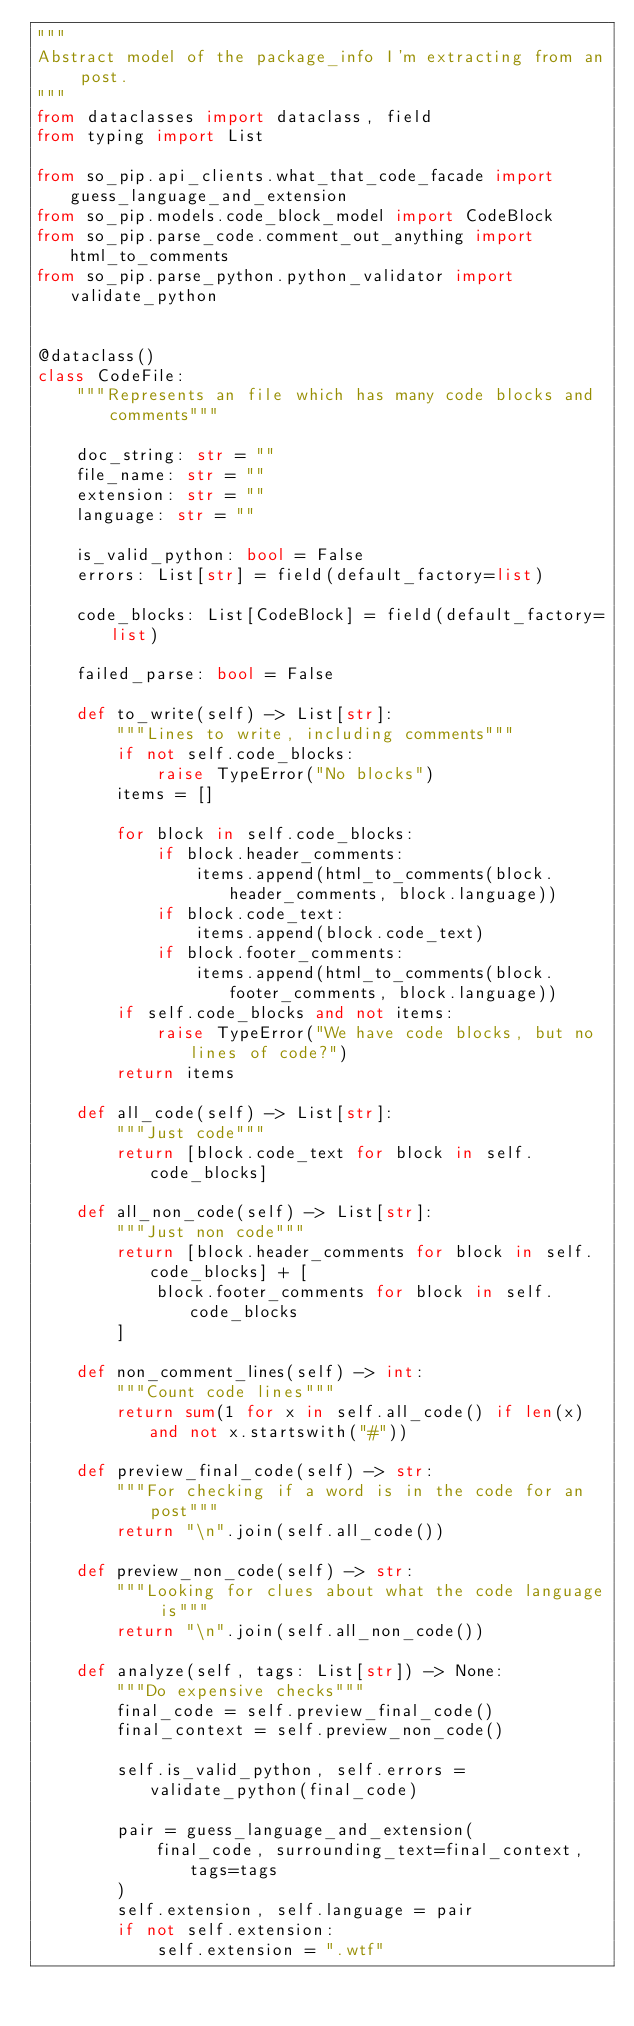<code> <loc_0><loc_0><loc_500><loc_500><_Python_>"""
Abstract model of the package_info I'm extracting from an post.
"""
from dataclasses import dataclass, field
from typing import List

from so_pip.api_clients.what_that_code_facade import guess_language_and_extension
from so_pip.models.code_block_model import CodeBlock
from so_pip.parse_code.comment_out_anything import html_to_comments
from so_pip.parse_python.python_validator import validate_python


@dataclass()
class CodeFile:
    """Represents an file which has many code blocks and comments"""

    doc_string: str = ""
    file_name: str = ""
    extension: str = ""
    language: str = ""

    is_valid_python: bool = False
    errors: List[str] = field(default_factory=list)

    code_blocks: List[CodeBlock] = field(default_factory=list)

    failed_parse: bool = False

    def to_write(self) -> List[str]:
        """Lines to write, including comments"""
        if not self.code_blocks:
            raise TypeError("No blocks")
        items = []

        for block in self.code_blocks:
            if block.header_comments:
                items.append(html_to_comments(block.header_comments, block.language))
            if block.code_text:
                items.append(block.code_text)
            if block.footer_comments:
                items.append(html_to_comments(block.footer_comments, block.language))
        if self.code_blocks and not items:
            raise TypeError("We have code blocks, but no lines of code?")
        return items

    def all_code(self) -> List[str]:
        """Just code"""
        return [block.code_text for block in self.code_blocks]

    def all_non_code(self) -> List[str]:
        """Just non code"""
        return [block.header_comments for block in self.code_blocks] + [
            block.footer_comments for block in self.code_blocks
        ]

    def non_comment_lines(self) -> int:
        """Count code lines"""
        return sum(1 for x in self.all_code() if len(x) and not x.startswith("#"))

    def preview_final_code(self) -> str:
        """For checking if a word is in the code for an post"""
        return "\n".join(self.all_code())

    def preview_non_code(self) -> str:
        """Looking for clues about what the code language is"""
        return "\n".join(self.all_non_code())

    def analyze(self, tags: List[str]) -> None:
        """Do expensive checks"""
        final_code = self.preview_final_code()
        final_context = self.preview_non_code()

        self.is_valid_python, self.errors = validate_python(final_code)

        pair = guess_language_and_extension(
            final_code, surrounding_text=final_context, tags=tags
        )
        self.extension, self.language = pair
        if not self.extension:
            self.extension = ".wtf"
</code> 